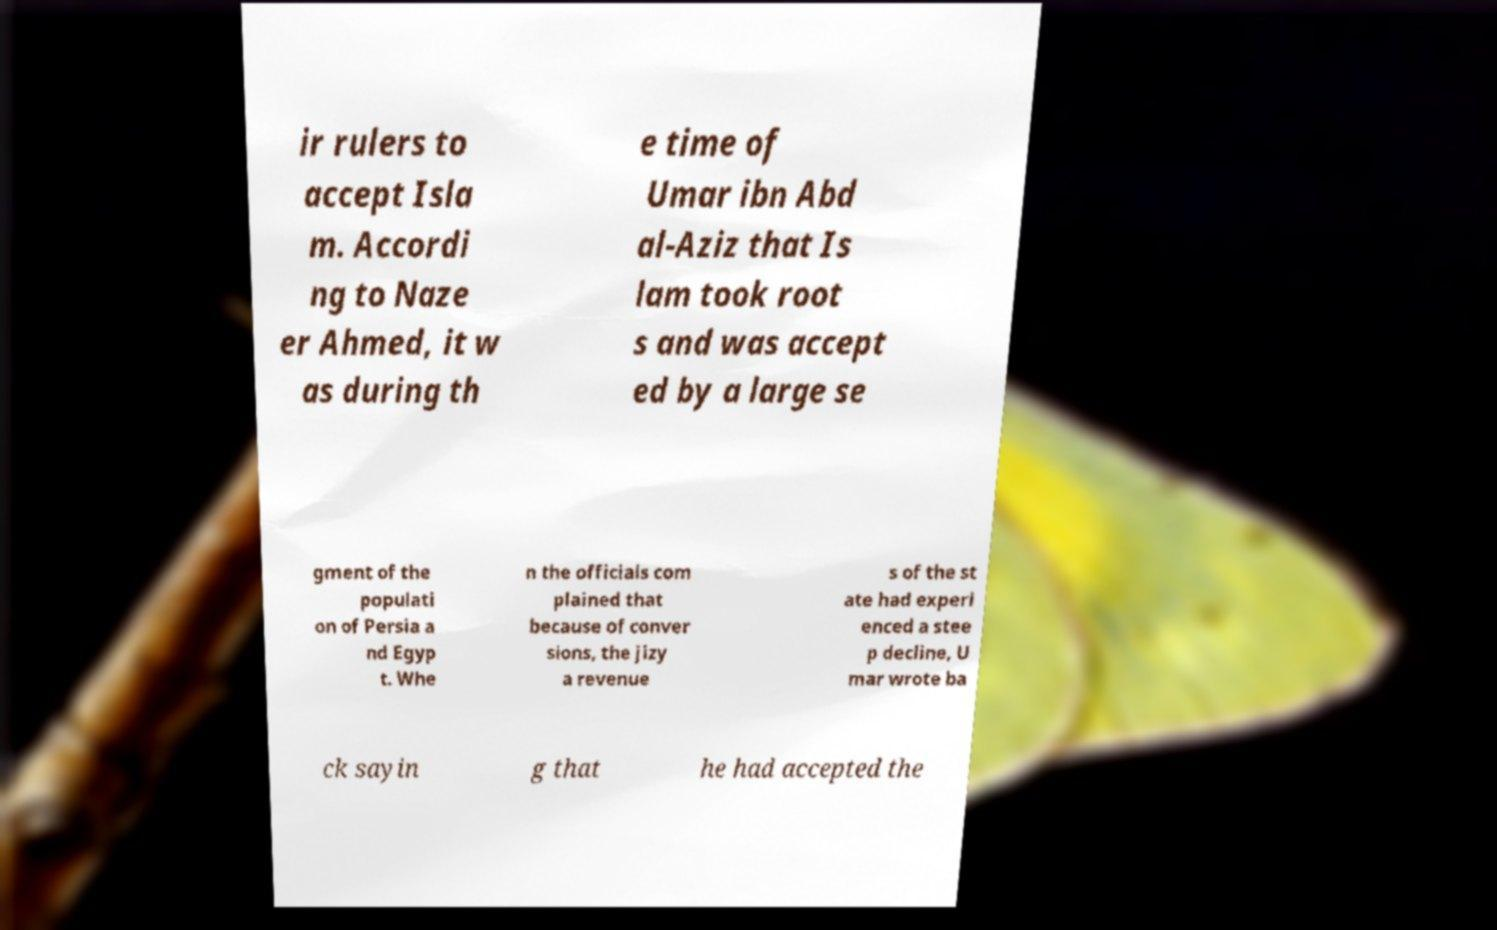I need the written content from this picture converted into text. Can you do that? ir rulers to accept Isla m. Accordi ng to Naze er Ahmed, it w as during th e time of Umar ibn Abd al-Aziz that Is lam took root s and was accept ed by a large se gment of the populati on of Persia a nd Egyp t. Whe n the officials com plained that because of conver sions, the jizy a revenue s of the st ate had experi enced a stee p decline, U mar wrote ba ck sayin g that he had accepted the 